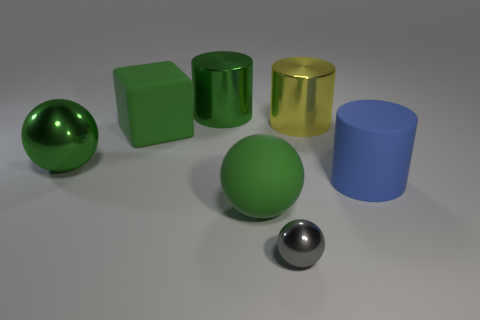Is the object behind the big yellow shiny object made of the same material as the blue cylinder? no 